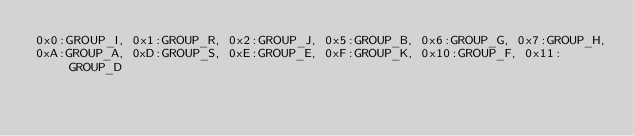Convert code to text. <code><loc_0><loc_0><loc_500><loc_500><_YAML_>0x0:GROUP_I, 0x1:GROUP_R, 0x2:GROUP_J, 0x5:GROUP_B, 0x6:GROUP_G, 0x7:GROUP_H,
0xA:GROUP_A, 0xD:GROUP_S, 0xE:GROUP_E, 0xF:GROUP_K, 0x10:GROUP_F, 0x11:GROUP_D
</code> 